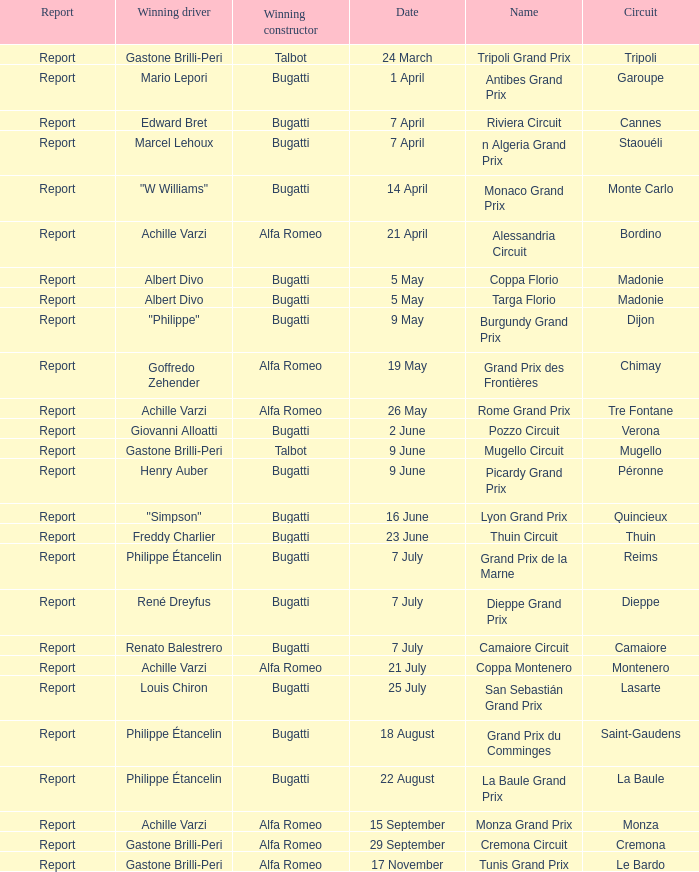What Winning driver has a Winning constructor of talbot? Gastone Brilli-Peri, Gastone Brilli-Peri. 